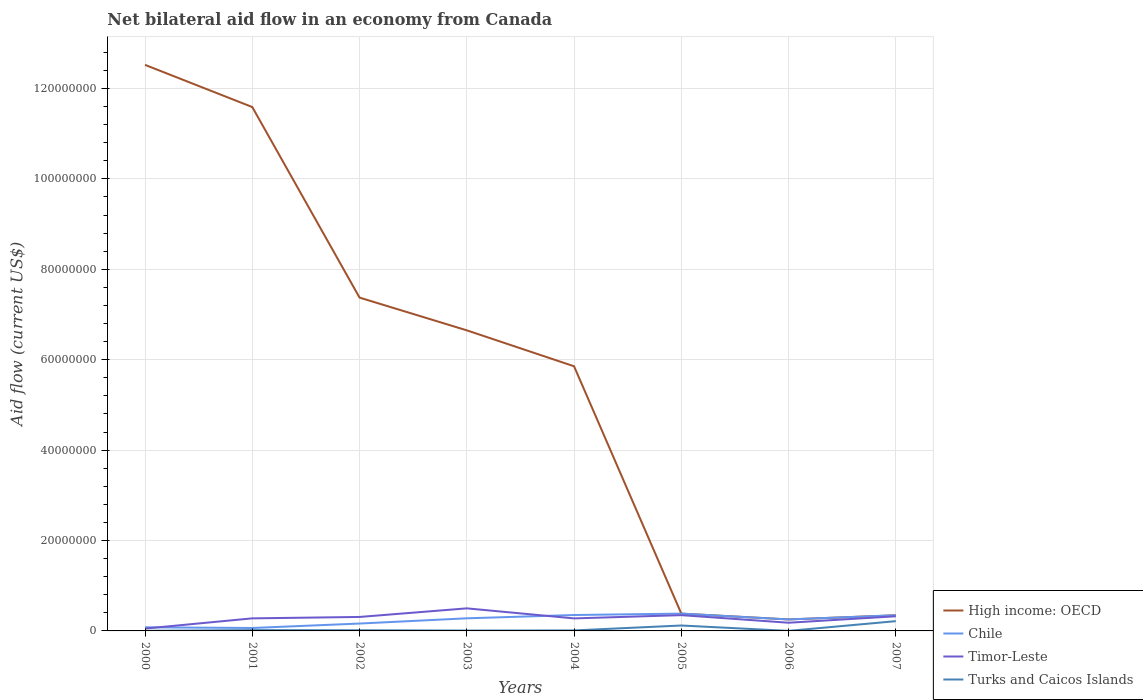Does the line corresponding to Chile intersect with the line corresponding to High income: OECD?
Offer a terse response. Yes. Is the number of lines equal to the number of legend labels?
Give a very brief answer. Yes. Across all years, what is the maximum net bilateral aid flow in Chile?
Your answer should be compact. 6.50e+05. What is the total net bilateral aid flow in High income: OECD in the graph?
Ensure brevity in your answer.  1.21e+08. What is the difference between the highest and the second highest net bilateral aid flow in Turks and Caicos Islands?
Offer a terse response. 2.15e+06. Is the net bilateral aid flow in Chile strictly greater than the net bilateral aid flow in Timor-Leste over the years?
Your answer should be very brief. No. How many lines are there?
Your response must be concise. 4. Are the values on the major ticks of Y-axis written in scientific E-notation?
Your response must be concise. No. How many legend labels are there?
Make the answer very short. 4. What is the title of the graph?
Ensure brevity in your answer.  Net bilateral aid flow in an economy from Canada. Does "Slovenia" appear as one of the legend labels in the graph?
Provide a succinct answer. No. What is the label or title of the X-axis?
Offer a very short reply. Years. What is the Aid flow (current US$) of High income: OECD in 2000?
Provide a succinct answer. 1.25e+08. What is the Aid flow (current US$) of Chile in 2000?
Make the answer very short. 8.00e+05. What is the Aid flow (current US$) in Timor-Leste in 2000?
Make the answer very short. 5.20e+05. What is the Aid flow (current US$) of Turks and Caicos Islands in 2000?
Provide a succinct answer. 3.00e+04. What is the Aid flow (current US$) of High income: OECD in 2001?
Offer a very short reply. 1.16e+08. What is the Aid flow (current US$) in Chile in 2001?
Keep it short and to the point. 6.50e+05. What is the Aid flow (current US$) of Timor-Leste in 2001?
Offer a terse response. 2.78e+06. What is the Aid flow (current US$) of High income: OECD in 2002?
Give a very brief answer. 7.37e+07. What is the Aid flow (current US$) in Chile in 2002?
Give a very brief answer. 1.63e+06. What is the Aid flow (current US$) in Timor-Leste in 2002?
Provide a short and direct response. 3.09e+06. What is the Aid flow (current US$) in Turks and Caicos Islands in 2002?
Ensure brevity in your answer.  1.50e+05. What is the Aid flow (current US$) of High income: OECD in 2003?
Give a very brief answer. 6.65e+07. What is the Aid flow (current US$) in Chile in 2003?
Give a very brief answer. 2.79e+06. What is the Aid flow (current US$) of Timor-Leste in 2003?
Offer a terse response. 4.99e+06. What is the Aid flow (current US$) in Turks and Caicos Islands in 2003?
Offer a terse response. 8.00e+04. What is the Aid flow (current US$) in High income: OECD in 2004?
Provide a succinct answer. 5.85e+07. What is the Aid flow (current US$) of Chile in 2004?
Your answer should be compact. 3.52e+06. What is the Aid flow (current US$) of Timor-Leste in 2004?
Ensure brevity in your answer.  2.77e+06. What is the Aid flow (current US$) of Turks and Caicos Islands in 2004?
Your response must be concise. 1.10e+05. What is the Aid flow (current US$) in High income: OECD in 2005?
Your response must be concise. 3.83e+06. What is the Aid flow (current US$) in Chile in 2005?
Ensure brevity in your answer.  3.83e+06. What is the Aid flow (current US$) of Timor-Leste in 2005?
Keep it short and to the point. 3.49e+06. What is the Aid flow (current US$) of Turks and Caicos Islands in 2005?
Offer a very short reply. 1.20e+06. What is the Aid flow (current US$) in High income: OECD in 2006?
Your answer should be compact. 2.54e+06. What is the Aid flow (current US$) of Chile in 2006?
Provide a short and direct response. 2.54e+06. What is the Aid flow (current US$) in Timor-Leste in 2006?
Ensure brevity in your answer.  1.81e+06. What is the Aid flow (current US$) of High income: OECD in 2007?
Provide a succinct answer. 3.46e+06. What is the Aid flow (current US$) in Chile in 2007?
Your response must be concise. 3.46e+06. What is the Aid flow (current US$) in Timor-Leste in 2007?
Your answer should be very brief. 3.24e+06. What is the Aid flow (current US$) in Turks and Caicos Islands in 2007?
Ensure brevity in your answer.  2.16e+06. Across all years, what is the maximum Aid flow (current US$) of High income: OECD?
Provide a short and direct response. 1.25e+08. Across all years, what is the maximum Aid flow (current US$) in Chile?
Your answer should be very brief. 3.83e+06. Across all years, what is the maximum Aid flow (current US$) of Timor-Leste?
Your response must be concise. 4.99e+06. Across all years, what is the maximum Aid flow (current US$) of Turks and Caicos Islands?
Offer a terse response. 2.16e+06. Across all years, what is the minimum Aid flow (current US$) in High income: OECD?
Your answer should be very brief. 2.54e+06. Across all years, what is the minimum Aid flow (current US$) in Chile?
Ensure brevity in your answer.  6.50e+05. Across all years, what is the minimum Aid flow (current US$) of Timor-Leste?
Your answer should be compact. 5.20e+05. Across all years, what is the minimum Aid flow (current US$) in Turks and Caicos Islands?
Your answer should be very brief. 10000. What is the total Aid flow (current US$) of High income: OECD in the graph?
Offer a terse response. 4.50e+08. What is the total Aid flow (current US$) of Chile in the graph?
Keep it short and to the point. 1.92e+07. What is the total Aid flow (current US$) of Timor-Leste in the graph?
Keep it short and to the point. 2.27e+07. What is the total Aid flow (current US$) in Turks and Caicos Islands in the graph?
Your answer should be very brief. 3.92e+06. What is the difference between the Aid flow (current US$) of High income: OECD in 2000 and that in 2001?
Keep it short and to the point. 9.33e+06. What is the difference between the Aid flow (current US$) of Chile in 2000 and that in 2001?
Your answer should be compact. 1.50e+05. What is the difference between the Aid flow (current US$) of Timor-Leste in 2000 and that in 2001?
Your answer should be compact. -2.26e+06. What is the difference between the Aid flow (current US$) in Turks and Caicos Islands in 2000 and that in 2001?
Keep it short and to the point. -1.50e+05. What is the difference between the Aid flow (current US$) in High income: OECD in 2000 and that in 2002?
Your answer should be compact. 5.15e+07. What is the difference between the Aid flow (current US$) of Chile in 2000 and that in 2002?
Provide a short and direct response. -8.30e+05. What is the difference between the Aid flow (current US$) in Timor-Leste in 2000 and that in 2002?
Give a very brief answer. -2.57e+06. What is the difference between the Aid flow (current US$) in High income: OECD in 2000 and that in 2003?
Your answer should be very brief. 5.87e+07. What is the difference between the Aid flow (current US$) of Chile in 2000 and that in 2003?
Ensure brevity in your answer.  -1.99e+06. What is the difference between the Aid flow (current US$) of Timor-Leste in 2000 and that in 2003?
Your response must be concise. -4.47e+06. What is the difference between the Aid flow (current US$) of High income: OECD in 2000 and that in 2004?
Keep it short and to the point. 6.67e+07. What is the difference between the Aid flow (current US$) in Chile in 2000 and that in 2004?
Your response must be concise. -2.72e+06. What is the difference between the Aid flow (current US$) of Timor-Leste in 2000 and that in 2004?
Keep it short and to the point. -2.25e+06. What is the difference between the Aid flow (current US$) in High income: OECD in 2000 and that in 2005?
Make the answer very short. 1.21e+08. What is the difference between the Aid flow (current US$) in Chile in 2000 and that in 2005?
Offer a very short reply. -3.03e+06. What is the difference between the Aid flow (current US$) in Timor-Leste in 2000 and that in 2005?
Make the answer very short. -2.97e+06. What is the difference between the Aid flow (current US$) of Turks and Caicos Islands in 2000 and that in 2005?
Provide a succinct answer. -1.17e+06. What is the difference between the Aid flow (current US$) in High income: OECD in 2000 and that in 2006?
Give a very brief answer. 1.23e+08. What is the difference between the Aid flow (current US$) of Chile in 2000 and that in 2006?
Your response must be concise. -1.74e+06. What is the difference between the Aid flow (current US$) of Timor-Leste in 2000 and that in 2006?
Your response must be concise. -1.29e+06. What is the difference between the Aid flow (current US$) of High income: OECD in 2000 and that in 2007?
Give a very brief answer. 1.22e+08. What is the difference between the Aid flow (current US$) in Chile in 2000 and that in 2007?
Offer a terse response. -2.66e+06. What is the difference between the Aid flow (current US$) of Timor-Leste in 2000 and that in 2007?
Offer a terse response. -2.72e+06. What is the difference between the Aid flow (current US$) in Turks and Caicos Islands in 2000 and that in 2007?
Your response must be concise. -2.13e+06. What is the difference between the Aid flow (current US$) in High income: OECD in 2001 and that in 2002?
Ensure brevity in your answer.  4.22e+07. What is the difference between the Aid flow (current US$) in Chile in 2001 and that in 2002?
Offer a terse response. -9.80e+05. What is the difference between the Aid flow (current US$) in Timor-Leste in 2001 and that in 2002?
Ensure brevity in your answer.  -3.10e+05. What is the difference between the Aid flow (current US$) of High income: OECD in 2001 and that in 2003?
Ensure brevity in your answer.  4.94e+07. What is the difference between the Aid flow (current US$) of Chile in 2001 and that in 2003?
Offer a terse response. -2.14e+06. What is the difference between the Aid flow (current US$) in Timor-Leste in 2001 and that in 2003?
Make the answer very short. -2.21e+06. What is the difference between the Aid flow (current US$) of High income: OECD in 2001 and that in 2004?
Provide a short and direct response. 5.73e+07. What is the difference between the Aid flow (current US$) in Chile in 2001 and that in 2004?
Your answer should be very brief. -2.87e+06. What is the difference between the Aid flow (current US$) in High income: OECD in 2001 and that in 2005?
Ensure brevity in your answer.  1.12e+08. What is the difference between the Aid flow (current US$) of Chile in 2001 and that in 2005?
Give a very brief answer. -3.18e+06. What is the difference between the Aid flow (current US$) in Timor-Leste in 2001 and that in 2005?
Give a very brief answer. -7.10e+05. What is the difference between the Aid flow (current US$) of Turks and Caicos Islands in 2001 and that in 2005?
Keep it short and to the point. -1.02e+06. What is the difference between the Aid flow (current US$) in High income: OECD in 2001 and that in 2006?
Offer a very short reply. 1.13e+08. What is the difference between the Aid flow (current US$) in Chile in 2001 and that in 2006?
Your answer should be compact. -1.89e+06. What is the difference between the Aid flow (current US$) of Timor-Leste in 2001 and that in 2006?
Your answer should be compact. 9.70e+05. What is the difference between the Aid flow (current US$) in High income: OECD in 2001 and that in 2007?
Offer a very short reply. 1.12e+08. What is the difference between the Aid flow (current US$) of Chile in 2001 and that in 2007?
Ensure brevity in your answer.  -2.81e+06. What is the difference between the Aid flow (current US$) in Timor-Leste in 2001 and that in 2007?
Your answer should be very brief. -4.60e+05. What is the difference between the Aid flow (current US$) in Turks and Caicos Islands in 2001 and that in 2007?
Offer a very short reply. -1.98e+06. What is the difference between the Aid flow (current US$) of High income: OECD in 2002 and that in 2003?
Offer a very short reply. 7.24e+06. What is the difference between the Aid flow (current US$) in Chile in 2002 and that in 2003?
Provide a succinct answer. -1.16e+06. What is the difference between the Aid flow (current US$) in Timor-Leste in 2002 and that in 2003?
Ensure brevity in your answer.  -1.90e+06. What is the difference between the Aid flow (current US$) of Turks and Caicos Islands in 2002 and that in 2003?
Make the answer very short. 7.00e+04. What is the difference between the Aid flow (current US$) in High income: OECD in 2002 and that in 2004?
Make the answer very short. 1.52e+07. What is the difference between the Aid flow (current US$) of Chile in 2002 and that in 2004?
Make the answer very short. -1.89e+06. What is the difference between the Aid flow (current US$) of Timor-Leste in 2002 and that in 2004?
Provide a succinct answer. 3.20e+05. What is the difference between the Aid flow (current US$) of Turks and Caicos Islands in 2002 and that in 2004?
Offer a very short reply. 4.00e+04. What is the difference between the Aid flow (current US$) of High income: OECD in 2002 and that in 2005?
Make the answer very short. 6.99e+07. What is the difference between the Aid flow (current US$) of Chile in 2002 and that in 2005?
Provide a short and direct response. -2.20e+06. What is the difference between the Aid flow (current US$) of Timor-Leste in 2002 and that in 2005?
Offer a very short reply. -4.00e+05. What is the difference between the Aid flow (current US$) in Turks and Caicos Islands in 2002 and that in 2005?
Offer a very short reply. -1.05e+06. What is the difference between the Aid flow (current US$) in High income: OECD in 2002 and that in 2006?
Your answer should be very brief. 7.12e+07. What is the difference between the Aid flow (current US$) of Chile in 2002 and that in 2006?
Make the answer very short. -9.10e+05. What is the difference between the Aid flow (current US$) of Timor-Leste in 2002 and that in 2006?
Ensure brevity in your answer.  1.28e+06. What is the difference between the Aid flow (current US$) in High income: OECD in 2002 and that in 2007?
Your response must be concise. 7.03e+07. What is the difference between the Aid flow (current US$) of Chile in 2002 and that in 2007?
Your response must be concise. -1.83e+06. What is the difference between the Aid flow (current US$) of Timor-Leste in 2002 and that in 2007?
Provide a short and direct response. -1.50e+05. What is the difference between the Aid flow (current US$) of Turks and Caicos Islands in 2002 and that in 2007?
Provide a short and direct response. -2.01e+06. What is the difference between the Aid flow (current US$) of High income: OECD in 2003 and that in 2004?
Keep it short and to the point. 7.95e+06. What is the difference between the Aid flow (current US$) of Chile in 2003 and that in 2004?
Offer a very short reply. -7.30e+05. What is the difference between the Aid flow (current US$) in Timor-Leste in 2003 and that in 2004?
Provide a succinct answer. 2.22e+06. What is the difference between the Aid flow (current US$) in High income: OECD in 2003 and that in 2005?
Your response must be concise. 6.27e+07. What is the difference between the Aid flow (current US$) of Chile in 2003 and that in 2005?
Keep it short and to the point. -1.04e+06. What is the difference between the Aid flow (current US$) of Timor-Leste in 2003 and that in 2005?
Provide a short and direct response. 1.50e+06. What is the difference between the Aid flow (current US$) in Turks and Caicos Islands in 2003 and that in 2005?
Provide a succinct answer. -1.12e+06. What is the difference between the Aid flow (current US$) of High income: OECD in 2003 and that in 2006?
Your response must be concise. 6.40e+07. What is the difference between the Aid flow (current US$) of Timor-Leste in 2003 and that in 2006?
Your answer should be compact. 3.18e+06. What is the difference between the Aid flow (current US$) in High income: OECD in 2003 and that in 2007?
Make the answer very short. 6.30e+07. What is the difference between the Aid flow (current US$) in Chile in 2003 and that in 2007?
Ensure brevity in your answer.  -6.70e+05. What is the difference between the Aid flow (current US$) of Timor-Leste in 2003 and that in 2007?
Your response must be concise. 1.75e+06. What is the difference between the Aid flow (current US$) in Turks and Caicos Islands in 2003 and that in 2007?
Provide a short and direct response. -2.08e+06. What is the difference between the Aid flow (current US$) of High income: OECD in 2004 and that in 2005?
Your response must be concise. 5.47e+07. What is the difference between the Aid flow (current US$) in Chile in 2004 and that in 2005?
Offer a very short reply. -3.10e+05. What is the difference between the Aid flow (current US$) of Timor-Leste in 2004 and that in 2005?
Give a very brief answer. -7.20e+05. What is the difference between the Aid flow (current US$) of Turks and Caicos Islands in 2004 and that in 2005?
Keep it short and to the point. -1.09e+06. What is the difference between the Aid flow (current US$) in High income: OECD in 2004 and that in 2006?
Ensure brevity in your answer.  5.60e+07. What is the difference between the Aid flow (current US$) in Chile in 2004 and that in 2006?
Offer a terse response. 9.80e+05. What is the difference between the Aid flow (current US$) in Timor-Leste in 2004 and that in 2006?
Your response must be concise. 9.60e+05. What is the difference between the Aid flow (current US$) of Turks and Caicos Islands in 2004 and that in 2006?
Make the answer very short. 1.00e+05. What is the difference between the Aid flow (current US$) of High income: OECD in 2004 and that in 2007?
Give a very brief answer. 5.51e+07. What is the difference between the Aid flow (current US$) of Chile in 2004 and that in 2007?
Make the answer very short. 6.00e+04. What is the difference between the Aid flow (current US$) in Timor-Leste in 2004 and that in 2007?
Your answer should be very brief. -4.70e+05. What is the difference between the Aid flow (current US$) of Turks and Caicos Islands in 2004 and that in 2007?
Your answer should be compact. -2.05e+06. What is the difference between the Aid flow (current US$) in High income: OECD in 2005 and that in 2006?
Give a very brief answer. 1.29e+06. What is the difference between the Aid flow (current US$) of Chile in 2005 and that in 2006?
Offer a terse response. 1.29e+06. What is the difference between the Aid flow (current US$) of Timor-Leste in 2005 and that in 2006?
Offer a terse response. 1.68e+06. What is the difference between the Aid flow (current US$) of Turks and Caicos Islands in 2005 and that in 2006?
Your answer should be very brief. 1.19e+06. What is the difference between the Aid flow (current US$) in Turks and Caicos Islands in 2005 and that in 2007?
Offer a terse response. -9.60e+05. What is the difference between the Aid flow (current US$) in High income: OECD in 2006 and that in 2007?
Make the answer very short. -9.20e+05. What is the difference between the Aid flow (current US$) in Chile in 2006 and that in 2007?
Make the answer very short. -9.20e+05. What is the difference between the Aid flow (current US$) of Timor-Leste in 2006 and that in 2007?
Keep it short and to the point. -1.43e+06. What is the difference between the Aid flow (current US$) of Turks and Caicos Islands in 2006 and that in 2007?
Your response must be concise. -2.15e+06. What is the difference between the Aid flow (current US$) in High income: OECD in 2000 and the Aid flow (current US$) in Chile in 2001?
Your response must be concise. 1.25e+08. What is the difference between the Aid flow (current US$) of High income: OECD in 2000 and the Aid flow (current US$) of Timor-Leste in 2001?
Your response must be concise. 1.22e+08. What is the difference between the Aid flow (current US$) in High income: OECD in 2000 and the Aid flow (current US$) in Turks and Caicos Islands in 2001?
Ensure brevity in your answer.  1.25e+08. What is the difference between the Aid flow (current US$) in Chile in 2000 and the Aid flow (current US$) in Timor-Leste in 2001?
Your answer should be very brief. -1.98e+06. What is the difference between the Aid flow (current US$) of Chile in 2000 and the Aid flow (current US$) of Turks and Caicos Islands in 2001?
Ensure brevity in your answer.  6.20e+05. What is the difference between the Aid flow (current US$) of Timor-Leste in 2000 and the Aid flow (current US$) of Turks and Caicos Islands in 2001?
Provide a short and direct response. 3.40e+05. What is the difference between the Aid flow (current US$) in High income: OECD in 2000 and the Aid flow (current US$) in Chile in 2002?
Offer a very short reply. 1.24e+08. What is the difference between the Aid flow (current US$) of High income: OECD in 2000 and the Aid flow (current US$) of Timor-Leste in 2002?
Offer a very short reply. 1.22e+08. What is the difference between the Aid flow (current US$) of High income: OECD in 2000 and the Aid flow (current US$) of Turks and Caicos Islands in 2002?
Offer a terse response. 1.25e+08. What is the difference between the Aid flow (current US$) of Chile in 2000 and the Aid flow (current US$) of Timor-Leste in 2002?
Ensure brevity in your answer.  -2.29e+06. What is the difference between the Aid flow (current US$) of Chile in 2000 and the Aid flow (current US$) of Turks and Caicos Islands in 2002?
Provide a short and direct response. 6.50e+05. What is the difference between the Aid flow (current US$) of High income: OECD in 2000 and the Aid flow (current US$) of Chile in 2003?
Your answer should be compact. 1.22e+08. What is the difference between the Aid flow (current US$) of High income: OECD in 2000 and the Aid flow (current US$) of Timor-Leste in 2003?
Keep it short and to the point. 1.20e+08. What is the difference between the Aid flow (current US$) of High income: OECD in 2000 and the Aid flow (current US$) of Turks and Caicos Islands in 2003?
Ensure brevity in your answer.  1.25e+08. What is the difference between the Aid flow (current US$) in Chile in 2000 and the Aid flow (current US$) in Timor-Leste in 2003?
Your response must be concise. -4.19e+06. What is the difference between the Aid flow (current US$) in Chile in 2000 and the Aid flow (current US$) in Turks and Caicos Islands in 2003?
Offer a terse response. 7.20e+05. What is the difference between the Aid flow (current US$) of High income: OECD in 2000 and the Aid flow (current US$) of Chile in 2004?
Keep it short and to the point. 1.22e+08. What is the difference between the Aid flow (current US$) of High income: OECD in 2000 and the Aid flow (current US$) of Timor-Leste in 2004?
Ensure brevity in your answer.  1.22e+08. What is the difference between the Aid flow (current US$) in High income: OECD in 2000 and the Aid flow (current US$) in Turks and Caicos Islands in 2004?
Give a very brief answer. 1.25e+08. What is the difference between the Aid flow (current US$) in Chile in 2000 and the Aid flow (current US$) in Timor-Leste in 2004?
Your answer should be compact. -1.97e+06. What is the difference between the Aid flow (current US$) in Chile in 2000 and the Aid flow (current US$) in Turks and Caicos Islands in 2004?
Offer a very short reply. 6.90e+05. What is the difference between the Aid flow (current US$) of Timor-Leste in 2000 and the Aid flow (current US$) of Turks and Caicos Islands in 2004?
Ensure brevity in your answer.  4.10e+05. What is the difference between the Aid flow (current US$) in High income: OECD in 2000 and the Aid flow (current US$) in Chile in 2005?
Your answer should be compact. 1.21e+08. What is the difference between the Aid flow (current US$) of High income: OECD in 2000 and the Aid flow (current US$) of Timor-Leste in 2005?
Your answer should be compact. 1.22e+08. What is the difference between the Aid flow (current US$) of High income: OECD in 2000 and the Aid flow (current US$) of Turks and Caicos Islands in 2005?
Your answer should be compact. 1.24e+08. What is the difference between the Aid flow (current US$) of Chile in 2000 and the Aid flow (current US$) of Timor-Leste in 2005?
Provide a short and direct response. -2.69e+06. What is the difference between the Aid flow (current US$) of Chile in 2000 and the Aid flow (current US$) of Turks and Caicos Islands in 2005?
Provide a short and direct response. -4.00e+05. What is the difference between the Aid flow (current US$) in Timor-Leste in 2000 and the Aid flow (current US$) in Turks and Caicos Islands in 2005?
Make the answer very short. -6.80e+05. What is the difference between the Aid flow (current US$) in High income: OECD in 2000 and the Aid flow (current US$) in Chile in 2006?
Give a very brief answer. 1.23e+08. What is the difference between the Aid flow (current US$) in High income: OECD in 2000 and the Aid flow (current US$) in Timor-Leste in 2006?
Offer a very short reply. 1.23e+08. What is the difference between the Aid flow (current US$) of High income: OECD in 2000 and the Aid flow (current US$) of Turks and Caicos Islands in 2006?
Your response must be concise. 1.25e+08. What is the difference between the Aid flow (current US$) in Chile in 2000 and the Aid flow (current US$) in Timor-Leste in 2006?
Ensure brevity in your answer.  -1.01e+06. What is the difference between the Aid flow (current US$) in Chile in 2000 and the Aid flow (current US$) in Turks and Caicos Islands in 2006?
Keep it short and to the point. 7.90e+05. What is the difference between the Aid flow (current US$) of Timor-Leste in 2000 and the Aid flow (current US$) of Turks and Caicos Islands in 2006?
Provide a succinct answer. 5.10e+05. What is the difference between the Aid flow (current US$) of High income: OECD in 2000 and the Aid flow (current US$) of Chile in 2007?
Provide a short and direct response. 1.22e+08. What is the difference between the Aid flow (current US$) of High income: OECD in 2000 and the Aid flow (current US$) of Timor-Leste in 2007?
Offer a very short reply. 1.22e+08. What is the difference between the Aid flow (current US$) in High income: OECD in 2000 and the Aid flow (current US$) in Turks and Caicos Islands in 2007?
Your response must be concise. 1.23e+08. What is the difference between the Aid flow (current US$) of Chile in 2000 and the Aid flow (current US$) of Timor-Leste in 2007?
Make the answer very short. -2.44e+06. What is the difference between the Aid flow (current US$) of Chile in 2000 and the Aid flow (current US$) of Turks and Caicos Islands in 2007?
Your answer should be very brief. -1.36e+06. What is the difference between the Aid flow (current US$) in Timor-Leste in 2000 and the Aid flow (current US$) in Turks and Caicos Islands in 2007?
Your response must be concise. -1.64e+06. What is the difference between the Aid flow (current US$) of High income: OECD in 2001 and the Aid flow (current US$) of Chile in 2002?
Give a very brief answer. 1.14e+08. What is the difference between the Aid flow (current US$) in High income: OECD in 2001 and the Aid flow (current US$) in Timor-Leste in 2002?
Ensure brevity in your answer.  1.13e+08. What is the difference between the Aid flow (current US$) of High income: OECD in 2001 and the Aid flow (current US$) of Turks and Caicos Islands in 2002?
Your answer should be very brief. 1.16e+08. What is the difference between the Aid flow (current US$) in Chile in 2001 and the Aid flow (current US$) in Timor-Leste in 2002?
Offer a terse response. -2.44e+06. What is the difference between the Aid flow (current US$) of Chile in 2001 and the Aid flow (current US$) of Turks and Caicos Islands in 2002?
Keep it short and to the point. 5.00e+05. What is the difference between the Aid flow (current US$) in Timor-Leste in 2001 and the Aid flow (current US$) in Turks and Caicos Islands in 2002?
Provide a succinct answer. 2.63e+06. What is the difference between the Aid flow (current US$) in High income: OECD in 2001 and the Aid flow (current US$) in Chile in 2003?
Keep it short and to the point. 1.13e+08. What is the difference between the Aid flow (current US$) in High income: OECD in 2001 and the Aid flow (current US$) in Timor-Leste in 2003?
Your answer should be very brief. 1.11e+08. What is the difference between the Aid flow (current US$) of High income: OECD in 2001 and the Aid flow (current US$) of Turks and Caicos Islands in 2003?
Your answer should be compact. 1.16e+08. What is the difference between the Aid flow (current US$) in Chile in 2001 and the Aid flow (current US$) in Timor-Leste in 2003?
Offer a terse response. -4.34e+06. What is the difference between the Aid flow (current US$) in Chile in 2001 and the Aid flow (current US$) in Turks and Caicos Islands in 2003?
Your response must be concise. 5.70e+05. What is the difference between the Aid flow (current US$) in Timor-Leste in 2001 and the Aid flow (current US$) in Turks and Caicos Islands in 2003?
Your answer should be very brief. 2.70e+06. What is the difference between the Aid flow (current US$) of High income: OECD in 2001 and the Aid flow (current US$) of Chile in 2004?
Offer a very short reply. 1.12e+08. What is the difference between the Aid flow (current US$) of High income: OECD in 2001 and the Aid flow (current US$) of Timor-Leste in 2004?
Provide a short and direct response. 1.13e+08. What is the difference between the Aid flow (current US$) in High income: OECD in 2001 and the Aid flow (current US$) in Turks and Caicos Islands in 2004?
Your answer should be compact. 1.16e+08. What is the difference between the Aid flow (current US$) in Chile in 2001 and the Aid flow (current US$) in Timor-Leste in 2004?
Ensure brevity in your answer.  -2.12e+06. What is the difference between the Aid flow (current US$) of Chile in 2001 and the Aid flow (current US$) of Turks and Caicos Islands in 2004?
Give a very brief answer. 5.40e+05. What is the difference between the Aid flow (current US$) in Timor-Leste in 2001 and the Aid flow (current US$) in Turks and Caicos Islands in 2004?
Keep it short and to the point. 2.67e+06. What is the difference between the Aid flow (current US$) of High income: OECD in 2001 and the Aid flow (current US$) of Chile in 2005?
Your answer should be very brief. 1.12e+08. What is the difference between the Aid flow (current US$) of High income: OECD in 2001 and the Aid flow (current US$) of Timor-Leste in 2005?
Provide a short and direct response. 1.12e+08. What is the difference between the Aid flow (current US$) of High income: OECD in 2001 and the Aid flow (current US$) of Turks and Caicos Islands in 2005?
Your answer should be compact. 1.15e+08. What is the difference between the Aid flow (current US$) in Chile in 2001 and the Aid flow (current US$) in Timor-Leste in 2005?
Your answer should be very brief. -2.84e+06. What is the difference between the Aid flow (current US$) in Chile in 2001 and the Aid flow (current US$) in Turks and Caicos Islands in 2005?
Offer a terse response. -5.50e+05. What is the difference between the Aid flow (current US$) in Timor-Leste in 2001 and the Aid flow (current US$) in Turks and Caicos Islands in 2005?
Ensure brevity in your answer.  1.58e+06. What is the difference between the Aid flow (current US$) of High income: OECD in 2001 and the Aid flow (current US$) of Chile in 2006?
Provide a succinct answer. 1.13e+08. What is the difference between the Aid flow (current US$) of High income: OECD in 2001 and the Aid flow (current US$) of Timor-Leste in 2006?
Your response must be concise. 1.14e+08. What is the difference between the Aid flow (current US$) in High income: OECD in 2001 and the Aid flow (current US$) in Turks and Caicos Islands in 2006?
Your answer should be very brief. 1.16e+08. What is the difference between the Aid flow (current US$) of Chile in 2001 and the Aid flow (current US$) of Timor-Leste in 2006?
Offer a very short reply. -1.16e+06. What is the difference between the Aid flow (current US$) in Chile in 2001 and the Aid flow (current US$) in Turks and Caicos Islands in 2006?
Make the answer very short. 6.40e+05. What is the difference between the Aid flow (current US$) in Timor-Leste in 2001 and the Aid flow (current US$) in Turks and Caicos Islands in 2006?
Provide a succinct answer. 2.77e+06. What is the difference between the Aid flow (current US$) of High income: OECD in 2001 and the Aid flow (current US$) of Chile in 2007?
Provide a succinct answer. 1.12e+08. What is the difference between the Aid flow (current US$) in High income: OECD in 2001 and the Aid flow (current US$) in Timor-Leste in 2007?
Make the answer very short. 1.13e+08. What is the difference between the Aid flow (current US$) of High income: OECD in 2001 and the Aid flow (current US$) of Turks and Caicos Islands in 2007?
Keep it short and to the point. 1.14e+08. What is the difference between the Aid flow (current US$) in Chile in 2001 and the Aid flow (current US$) in Timor-Leste in 2007?
Provide a short and direct response. -2.59e+06. What is the difference between the Aid flow (current US$) in Chile in 2001 and the Aid flow (current US$) in Turks and Caicos Islands in 2007?
Offer a very short reply. -1.51e+06. What is the difference between the Aid flow (current US$) of Timor-Leste in 2001 and the Aid flow (current US$) of Turks and Caicos Islands in 2007?
Ensure brevity in your answer.  6.20e+05. What is the difference between the Aid flow (current US$) in High income: OECD in 2002 and the Aid flow (current US$) in Chile in 2003?
Your response must be concise. 7.09e+07. What is the difference between the Aid flow (current US$) in High income: OECD in 2002 and the Aid flow (current US$) in Timor-Leste in 2003?
Your answer should be very brief. 6.87e+07. What is the difference between the Aid flow (current US$) of High income: OECD in 2002 and the Aid flow (current US$) of Turks and Caicos Islands in 2003?
Offer a terse response. 7.36e+07. What is the difference between the Aid flow (current US$) in Chile in 2002 and the Aid flow (current US$) in Timor-Leste in 2003?
Make the answer very short. -3.36e+06. What is the difference between the Aid flow (current US$) of Chile in 2002 and the Aid flow (current US$) of Turks and Caicos Islands in 2003?
Your response must be concise. 1.55e+06. What is the difference between the Aid flow (current US$) in Timor-Leste in 2002 and the Aid flow (current US$) in Turks and Caicos Islands in 2003?
Your answer should be compact. 3.01e+06. What is the difference between the Aid flow (current US$) of High income: OECD in 2002 and the Aid flow (current US$) of Chile in 2004?
Ensure brevity in your answer.  7.02e+07. What is the difference between the Aid flow (current US$) of High income: OECD in 2002 and the Aid flow (current US$) of Timor-Leste in 2004?
Give a very brief answer. 7.10e+07. What is the difference between the Aid flow (current US$) of High income: OECD in 2002 and the Aid flow (current US$) of Turks and Caicos Islands in 2004?
Provide a succinct answer. 7.36e+07. What is the difference between the Aid flow (current US$) of Chile in 2002 and the Aid flow (current US$) of Timor-Leste in 2004?
Offer a terse response. -1.14e+06. What is the difference between the Aid flow (current US$) in Chile in 2002 and the Aid flow (current US$) in Turks and Caicos Islands in 2004?
Your response must be concise. 1.52e+06. What is the difference between the Aid flow (current US$) in Timor-Leste in 2002 and the Aid flow (current US$) in Turks and Caicos Islands in 2004?
Your response must be concise. 2.98e+06. What is the difference between the Aid flow (current US$) in High income: OECD in 2002 and the Aid flow (current US$) in Chile in 2005?
Give a very brief answer. 6.99e+07. What is the difference between the Aid flow (current US$) of High income: OECD in 2002 and the Aid flow (current US$) of Timor-Leste in 2005?
Provide a succinct answer. 7.02e+07. What is the difference between the Aid flow (current US$) of High income: OECD in 2002 and the Aid flow (current US$) of Turks and Caicos Islands in 2005?
Your answer should be compact. 7.25e+07. What is the difference between the Aid flow (current US$) in Chile in 2002 and the Aid flow (current US$) in Timor-Leste in 2005?
Keep it short and to the point. -1.86e+06. What is the difference between the Aid flow (current US$) in Timor-Leste in 2002 and the Aid flow (current US$) in Turks and Caicos Islands in 2005?
Offer a terse response. 1.89e+06. What is the difference between the Aid flow (current US$) of High income: OECD in 2002 and the Aid flow (current US$) of Chile in 2006?
Your answer should be compact. 7.12e+07. What is the difference between the Aid flow (current US$) of High income: OECD in 2002 and the Aid flow (current US$) of Timor-Leste in 2006?
Offer a terse response. 7.19e+07. What is the difference between the Aid flow (current US$) in High income: OECD in 2002 and the Aid flow (current US$) in Turks and Caicos Islands in 2006?
Your answer should be compact. 7.37e+07. What is the difference between the Aid flow (current US$) of Chile in 2002 and the Aid flow (current US$) of Turks and Caicos Islands in 2006?
Give a very brief answer. 1.62e+06. What is the difference between the Aid flow (current US$) in Timor-Leste in 2002 and the Aid flow (current US$) in Turks and Caicos Islands in 2006?
Provide a short and direct response. 3.08e+06. What is the difference between the Aid flow (current US$) of High income: OECD in 2002 and the Aid flow (current US$) of Chile in 2007?
Offer a terse response. 7.03e+07. What is the difference between the Aid flow (current US$) in High income: OECD in 2002 and the Aid flow (current US$) in Timor-Leste in 2007?
Offer a very short reply. 7.05e+07. What is the difference between the Aid flow (current US$) of High income: OECD in 2002 and the Aid flow (current US$) of Turks and Caicos Islands in 2007?
Provide a short and direct response. 7.16e+07. What is the difference between the Aid flow (current US$) of Chile in 2002 and the Aid flow (current US$) of Timor-Leste in 2007?
Provide a succinct answer. -1.61e+06. What is the difference between the Aid flow (current US$) of Chile in 2002 and the Aid flow (current US$) of Turks and Caicos Islands in 2007?
Offer a terse response. -5.30e+05. What is the difference between the Aid flow (current US$) in Timor-Leste in 2002 and the Aid flow (current US$) in Turks and Caicos Islands in 2007?
Make the answer very short. 9.30e+05. What is the difference between the Aid flow (current US$) in High income: OECD in 2003 and the Aid flow (current US$) in Chile in 2004?
Give a very brief answer. 6.30e+07. What is the difference between the Aid flow (current US$) in High income: OECD in 2003 and the Aid flow (current US$) in Timor-Leste in 2004?
Your answer should be very brief. 6.37e+07. What is the difference between the Aid flow (current US$) in High income: OECD in 2003 and the Aid flow (current US$) in Turks and Caicos Islands in 2004?
Your answer should be compact. 6.64e+07. What is the difference between the Aid flow (current US$) in Chile in 2003 and the Aid flow (current US$) in Turks and Caicos Islands in 2004?
Provide a short and direct response. 2.68e+06. What is the difference between the Aid flow (current US$) in Timor-Leste in 2003 and the Aid flow (current US$) in Turks and Caicos Islands in 2004?
Ensure brevity in your answer.  4.88e+06. What is the difference between the Aid flow (current US$) of High income: OECD in 2003 and the Aid flow (current US$) of Chile in 2005?
Ensure brevity in your answer.  6.27e+07. What is the difference between the Aid flow (current US$) of High income: OECD in 2003 and the Aid flow (current US$) of Timor-Leste in 2005?
Keep it short and to the point. 6.30e+07. What is the difference between the Aid flow (current US$) in High income: OECD in 2003 and the Aid flow (current US$) in Turks and Caicos Islands in 2005?
Offer a terse response. 6.53e+07. What is the difference between the Aid flow (current US$) in Chile in 2003 and the Aid flow (current US$) in Timor-Leste in 2005?
Offer a very short reply. -7.00e+05. What is the difference between the Aid flow (current US$) of Chile in 2003 and the Aid flow (current US$) of Turks and Caicos Islands in 2005?
Offer a terse response. 1.59e+06. What is the difference between the Aid flow (current US$) of Timor-Leste in 2003 and the Aid flow (current US$) of Turks and Caicos Islands in 2005?
Offer a terse response. 3.79e+06. What is the difference between the Aid flow (current US$) of High income: OECD in 2003 and the Aid flow (current US$) of Chile in 2006?
Give a very brief answer. 6.40e+07. What is the difference between the Aid flow (current US$) in High income: OECD in 2003 and the Aid flow (current US$) in Timor-Leste in 2006?
Your response must be concise. 6.47e+07. What is the difference between the Aid flow (current US$) of High income: OECD in 2003 and the Aid flow (current US$) of Turks and Caicos Islands in 2006?
Provide a succinct answer. 6.65e+07. What is the difference between the Aid flow (current US$) in Chile in 2003 and the Aid flow (current US$) in Timor-Leste in 2006?
Offer a terse response. 9.80e+05. What is the difference between the Aid flow (current US$) in Chile in 2003 and the Aid flow (current US$) in Turks and Caicos Islands in 2006?
Your response must be concise. 2.78e+06. What is the difference between the Aid flow (current US$) of Timor-Leste in 2003 and the Aid flow (current US$) of Turks and Caicos Islands in 2006?
Your answer should be compact. 4.98e+06. What is the difference between the Aid flow (current US$) in High income: OECD in 2003 and the Aid flow (current US$) in Chile in 2007?
Ensure brevity in your answer.  6.30e+07. What is the difference between the Aid flow (current US$) of High income: OECD in 2003 and the Aid flow (current US$) of Timor-Leste in 2007?
Make the answer very short. 6.32e+07. What is the difference between the Aid flow (current US$) of High income: OECD in 2003 and the Aid flow (current US$) of Turks and Caicos Islands in 2007?
Your answer should be compact. 6.43e+07. What is the difference between the Aid flow (current US$) in Chile in 2003 and the Aid flow (current US$) in Timor-Leste in 2007?
Offer a very short reply. -4.50e+05. What is the difference between the Aid flow (current US$) in Chile in 2003 and the Aid flow (current US$) in Turks and Caicos Islands in 2007?
Provide a succinct answer. 6.30e+05. What is the difference between the Aid flow (current US$) of Timor-Leste in 2003 and the Aid flow (current US$) of Turks and Caicos Islands in 2007?
Your answer should be very brief. 2.83e+06. What is the difference between the Aid flow (current US$) of High income: OECD in 2004 and the Aid flow (current US$) of Chile in 2005?
Provide a short and direct response. 5.47e+07. What is the difference between the Aid flow (current US$) in High income: OECD in 2004 and the Aid flow (current US$) in Timor-Leste in 2005?
Provide a succinct answer. 5.50e+07. What is the difference between the Aid flow (current US$) in High income: OECD in 2004 and the Aid flow (current US$) in Turks and Caicos Islands in 2005?
Provide a succinct answer. 5.73e+07. What is the difference between the Aid flow (current US$) in Chile in 2004 and the Aid flow (current US$) in Timor-Leste in 2005?
Offer a very short reply. 3.00e+04. What is the difference between the Aid flow (current US$) of Chile in 2004 and the Aid flow (current US$) of Turks and Caicos Islands in 2005?
Make the answer very short. 2.32e+06. What is the difference between the Aid flow (current US$) in Timor-Leste in 2004 and the Aid flow (current US$) in Turks and Caicos Islands in 2005?
Provide a short and direct response. 1.57e+06. What is the difference between the Aid flow (current US$) of High income: OECD in 2004 and the Aid flow (current US$) of Chile in 2006?
Make the answer very short. 5.60e+07. What is the difference between the Aid flow (current US$) of High income: OECD in 2004 and the Aid flow (current US$) of Timor-Leste in 2006?
Offer a very short reply. 5.67e+07. What is the difference between the Aid flow (current US$) in High income: OECD in 2004 and the Aid flow (current US$) in Turks and Caicos Islands in 2006?
Ensure brevity in your answer.  5.85e+07. What is the difference between the Aid flow (current US$) of Chile in 2004 and the Aid flow (current US$) of Timor-Leste in 2006?
Your response must be concise. 1.71e+06. What is the difference between the Aid flow (current US$) in Chile in 2004 and the Aid flow (current US$) in Turks and Caicos Islands in 2006?
Your answer should be compact. 3.51e+06. What is the difference between the Aid flow (current US$) in Timor-Leste in 2004 and the Aid flow (current US$) in Turks and Caicos Islands in 2006?
Your answer should be compact. 2.76e+06. What is the difference between the Aid flow (current US$) of High income: OECD in 2004 and the Aid flow (current US$) of Chile in 2007?
Offer a very short reply. 5.51e+07. What is the difference between the Aid flow (current US$) in High income: OECD in 2004 and the Aid flow (current US$) in Timor-Leste in 2007?
Offer a very short reply. 5.53e+07. What is the difference between the Aid flow (current US$) in High income: OECD in 2004 and the Aid flow (current US$) in Turks and Caicos Islands in 2007?
Keep it short and to the point. 5.64e+07. What is the difference between the Aid flow (current US$) in Chile in 2004 and the Aid flow (current US$) in Turks and Caicos Islands in 2007?
Offer a very short reply. 1.36e+06. What is the difference between the Aid flow (current US$) in High income: OECD in 2005 and the Aid flow (current US$) in Chile in 2006?
Your answer should be compact. 1.29e+06. What is the difference between the Aid flow (current US$) in High income: OECD in 2005 and the Aid flow (current US$) in Timor-Leste in 2006?
Make the answer very short. 2.02e+06. What is the difference between the Aid flow (current US$) of High income: OECD in 2005 and the Aid flow (current US$) of Turks and Caicos Islands in 2006?
Give a very brief answer. 3.82e+06. What is the difference between the Aid flow (current US$) in Chile in 2005 and the Aid flow (current US$) in Timor-Leste in 2006?
Ensure brevity in your answer.  2.02e+06. What is the difference between the Aid flow (current US$) in Chile in 2005 and the Aid flow (current US$) in Turks and Caicos Islands in 2006?
Offer a terse response. 3.82e+06. What is the difference between the Aid flow (current US$) in Timor-Leste in 2005 and the Aid flow (current US$) in Turks and Caicos Islands in 2006?
Give a very brief answer. 3.48e+06. What is the difference between the Aid flow (current US$) of High income: OECD in 2005 and the Aid flow (current US$) of Chile in 2007?
Provide a succinct answer. 3.70e+05. What is the difference between the Aid flow (current US$) in High income: OECD in 2005 and the Aid flow (current US$) in Timor-Leste in 2007?
Keep it short and to the point. 5.90e+05. What is the difference between the Aid flow (current US$) of High income: OECD in 2005 and the Aid flow (current US$) of Turks and Caicos Islands in 2007?
Ensure brevity in your answer.  1.67e+06. What is the difference between the Aid flow (current US$) of Chile in 2005 and the Aid flow (current US$) of Timor-Leste in 2007?
Provide a succinct answer. 5.90e+05. What is the difference between the Aid flow (current US$) of Chile in 2005 and the Aid flow (current US$) of Turks and Caicos Islands in 2007?
Ensure brevity in your answer.  1.67e+06. What is the difference between the Aid flow (current US$) in Timor-Leste in 2005 and the Aid flow (current US$) in Turks and Caicos Islands in 2007?
Give a very brief answer. 1.33e+06. What is the difference between the Aid flow (current US$) in High income: OECD in 2006 and the Aid flow (current US$) in Chile in 2007?
Offer a very short reply. -9.20e+05. What is the difference between the Aid flow (current US$) in High income: OECD in 2006 and the Aid flow (current US$) in Timor-Leste in 2007?
Give a very brief answer. -7.00e+05. What is the difference between the Aid flow (current US$) in High income: OECD in 2006 and the Aid flow (current US$) in Turks and Caicos Islands in 2007?
Ensure brevity in your answer.  3.80e+05. What is the difference between the Aid flow (current US$) in Chile in 2006 and the Aid flow (current US$) in Timor-Leste in 2007?
Offer a terse response. -7.00e+05. What is the difference between the Aid flow (current US$) of Chile in 2006 and the Aid flow (current US$) of Turks and Caicos Islands in 2007?
Make the answer very short. 3.80e+05. What is the difference between the Aid flow (current US$) of Timor-Leste in 2006 and the Aid flow (current US$) of Turks and Caicos Islands in 2007?
Your response must be concise. -3.50e+05. What is the average Aid flow (current US$) in High income: OECD per year?
Your answer should be compact. 5.62e+07. What is the average Aid flow (current US$) of Chile per year?
Offer a terse response. 2.40e+06. What is the average Aid flow (current US$) of Timor-Leste per year?
Provide a succinct answer. 2.84e+06. In the year 2000, what is the difference between the Aid flow (current US$) of High income: OECD and Aid flow (current US$) of Chile?
Your response must be concise. 1.24e+08. In the year 2000, what is the difference between the Aid flow (current US$) in High income: OECD and Aid flow (current US$) in Timor-Leste?
Give a very brief answer. 1.25e+08. In the year 2000, what is the difference between the Aid flow (current US$) in High income: OECD and Aid flow (current US$) in Turks and Caicos Islands?
Your answer should be very brief. 1.25e+08. In the year 2000, what is the difference between the Aid flow (current US$) of Chile and Aid flow (current US$) of Turks and Caicos Islands?
Provide a succinct answer. 7.70e+05. In the year 2000, what is the difference between the Aid flow (current US$) in Timor-Leste and Aid flow (current US$) in Turks and Caicos Islands?
Your response must be concise. 4.90e+05. In the year 2001, what is the difference between the Aid flow (current US$) in High income: OECD and Aid flow (current US$) in Chile?
Offer a terse response. 1.15e+08. In the year 2001, what is the difference between the Aid flow (current US$) in High income: OECD and Aid flow (current US$) in Timor-Leste?
Make the answer very short. 1.13e+08. In the year 2001, what is the difference between the Aid flow (current US$) of High income: OECD and Aid flow (current US$) of Turks and Caicos Islands?
Give a very brief answer. 1.16e+08. In the year 2001, what is the difference between the Aid flow (current US$) of Chile and Aid flow (current US$) of Timor-Leste?
Give a very brief answer. -2.13e+06. In the year 2001, what is the difference between the Aid flow (current US$) of Timor-Leste and Aid flow (current US$) of Turks and Caicos Islands?
Offer a terse response. 2.60e+06. In the year 2002, what is the difference between the Aid flow (current US$) of High income: OECD and Aid flow (current US$) of Chile?
Provide a short and direct response. 7.21e+07. In the year 2002, what is the difference between the Aid flow (current US$) of High income: OECD and Aid flow (current US$) of Timor-Leste?
Your response must be concise. 7.06e+07. In the year 2002, what is the difference between the Aid flow (current US$) of High income: OECD and Aid flow (current US$) of Turks and Caicos Islands?
Provide a succinct answer. 7.36e+07. In the year 2002, what is the difference between the Aid flow (current US$) of Chile and Aid flow (current US$) of Timor-Leste?
Provide a succinct answer. -1.46e+06. In the year 2002, what is the difference between the Aid flow (current US$) of Chile and Aid flow (current US$) of Turks and Caicos Islands?
Offer a very short reply. 1.48e+06. In the year 2002, what is the difference between the Aid flow (current US$) of Timor-Leste and Aid flow (current US$) of Turks and Caicos Islands?
Offer a very short reply. 2.94e+06. In the year 2003, what is the difference between the Aid flow (current US$) in High income: OECD and Aid flow (current US$) in Chile?
Provide a succinct answer. 6.37e+07. In the year 2003, what is the difference between the Aid flow (current US$) in High income: OECD and Aid flow (current US$) in Timor-Leste?
Your response must be concise. 6.15e+07. In the year 2003, what is the difference between the Aid flow (current US$) of High income: OECD and Aid flow (current US$) of Turks and Caicos Islands?
Keep it short and to the point. 6.64e+07. In the year 2003, what is the difference between the Aid flow (current US$) in Chile and Aid flow (current US$) in Timor-Leste?
Ensure brevity in your answer.  -2.20e+06. In the year 2003, what is the difference between the Aid flow (current US$) in Chile and Aid flow (current US$) in Turks and Caicos Islands?
Make the answer very short. 2.71e+06. In the year 2003, what is the difference between the Aid flow (current US$) in Timor-Leste and Aid flow (current US$) in Turks and Caicos Islands?
Offer a very short reply. 4.91e+06. In the year 2004, what is the difference between the Aid flow (current US$) of High income: OECD and Aid flow (current US$) of Chile?
Provide a succinct answer. 5.50e+07. In the year 2004, what is the difference between the Aid flow (current US$) of High income: OECD and Aid flow (current US$) of Timor-Leste?
Your response must be concise. 5.58e+07. In the year 2004, what is the difference between the Aid flow (current US$) in High income: OECD and Aid flow (current US$) in Turks and Caicos Islands?
Your answer should be very brief. 5.84e+07. In the year 2004, what is the difference between the Aid flow (current US$) of Chile and Aid flow (current US$) of Timor-Leste?
Provide a succinct answer. 7.50e+05. In the year 2004, what is the difference between the Aid flow (current US$) of Chile and Aid flow (current US$) of Turks and Caicos Islands?
Your answer should be very brief. 3.41e+06. In the year 2004, what is the difference between the Aid flow (current US$) of Timor-Leste and Aid flow (current US$) of Turks and Caicos Islands?
Your answer should be compact. 2.66e+06. In the year 2005, what is the difference between the Aid flow (current US$) in High income: OECD and Aid flow (current US$) in Timor-Leste?
Your answer should be very brief. 3.40e+05. In the year 2005, what is the difference between the Aid flow (current US$) of High income: OECD and Aid flow (current US$) of Turks and Caicos Islands?
Provide a succinct answer. 2.63e+06. In the year 2005, what is the difference between the Aid flow (current US$) of Chile and Aid flow (current US$) of Turks and Caicos Islands?
Give a very brief answer. 2.63e+06. In the year 2005, what is the difference between the Aid flow (current US$) in Timor-Leste and Aid flow (current US$) in Turks and Caicos Islands?
Provide a short and direct response. 2.29e+06. In the year 2006, what is the difference between the Aid flow (current US$) in High income: OECD and Aid flow (current US$) in Chile?
Your response must be concise. 0. In the year 2006, what is the difference between the Aid flow (current US$) in High income: OECD and Aid flow (current US$) in Timor-Leste?
Your response must be concise. 7.30e+05. In the year 2006, what is the difference between the Aid flow (current US$) in High income: OECD and Aid flow (current US$) in Turks and Caicos Islands?
Offer a very short reply. 2.53e+06. In the year 2006, what is the difference between the Aid flow (current US$) of Chile and Aid flow (current US$) of Timor-Leste?
Provide a succinct answer. 7.30e+05. In the year 2006, what is the difference between the Aid flow (current US$) in Chile and Aid flow (current US$) in Turks and Caicos Islands?
Make the answer very short. 2.53e+06. In the year 2006, what is the difference between the Aid flow (current US$) in Timor-Leste and Aid flow (current US$) in Turks and Caicos Islands?
Offer a terse response. 1.80e+06. In the year 2007, what is the difference between the Aid flow (current US$) of High income: OECD and Aid flow (current US$) of Chile?
Give a very brief answer. 0. In the year 2007, what is the difference between the Aid flow (current US$) of High income: OECD and Aid flow (current US$) of Turks and Caicos Islands?
Keep it short and to the point. 1.30e+06. In the year 2007, what is the difference between the Aid flow (current US$) in Chile and Aid flow (current US$) in Turks and Caicos Islands?
Offer a very short reply. 1.30e+06. In the year 2007, what is the difference between the Aid flow (current US$) in Timor-Leste and Aid flow (current US$) in Turks and Caicos Islands?
Give a very brief answer. 1.08e+06. What is the ratio of the Aid flow (current US$) of High income: OECD in 2000 to that in 2001?
Your answer should be compact. 1.08. What is the ratio of the Aid flow (current US$) of Chile in 2000 to that in 2001?
Offer a terse response. 1.23. What is the ratio of the Aid flow (current US$) of Timor-Leste in 2000 to that in 2001?
Offer a terse response. 0.19. What is the ratio of the Aid flow (current US$) in High income: OECD in 2000 to that in 2002?
Your answer should be very brief. 1.7. What is the ratio of the Aid flow (current US$) of Chile in 2000 to that in 2002?
Provide a succinct answer. 0.49. What is the ratio of the Aid flow (current US$) of Timor-Leste in 2000 to that in 2002?
Offer a terse response. 0.17. What is the ratio of the Aid flow (current US$) of Turks and Caicos Islands in 2000 to that in 2002?
Provide a succinct answer. 0.2. What is the ratio of the Aid flow (current US$) in High income: OECD in 2000 to that in 2003?
Offer a very short reply. 1.88. What is the ratio of the Aid flow (current US$) in Chile in 2000 to that in 2003?
Make the answer very short. 0.29. What is the ratio of the Aid flow (current US$) in Timor-Leste in 2000 to that in 2003?
Give a very brief answer. 0.1. What is the ratio of the Aid flow (current US$) of Turks and Caicos Islands in 2000 to that in 2003?
Your response must be concise. 0.38. What is the ratio of the Aid flow (current US$) of High income: OECD in 2000 to that in 2004?
Your response must be concise. 2.14. What is the ratio of the Aid flow (current US$) of Chile in 2000 to that in 2004?
Offer a very short reply. 0.23. What is the ratio of the Aid flow (current US$) of Timor-Leste in 2000 to that in 2004?
Make the answer very short. 0.19. What is the ratio of the Aid flow (current US$) of Turks and Caicos Islands in 2000 to that in 2004?
Provide a short and direct response. 0.27. What is the ratio of the Aid flow (current US$) in High income: OECD in 2000 to that in 2005?
Provide a short and direct response. 32.69. What is the ratio of the Aid flow (current US$) of Chile in 2000 to that in 2005?
Your response must be concise. 0.21. What is the ratio of the Aid flow (current US$) in Timor-Leste in 2000 to that in 2005?
Your answer should be very brief. 0.15. What is the ratio of the Aid flow (current US$) in Turks and Caicos Islands in 2000 to that in 2005?
Keep it short and to the point. 0.03. What is the ratio of the Aid flow (current US$) in High income: OECD in 2000 to that in 2006?
Provide a succinct answer. 49.3. What is the ratio of the Aid flow (current US$) of Chile in 2000 to that in 2006?
Offer a very short reply. 0.32. What is the ratio of the Aid flow (current US$) in Timor-Leste in 2000 to that in 2006?
Your answer should be very brief. 0.29. What is the ratio of the Aid flow (current US$) in High income: OECD in 2000 to that in 2007?
Keep it short and to the point. 36.19. What is the ratio of the Aid flow (current US$) in Chile in 2000 to that in 2007?
Your response must be concise. 0.23. What is the ratio of the Aid flow (current US$) of Timor-Leste in 2000 to that in 2007?
Ensure brevity in your answer.  0.16. What is the ratio of the Aid flow (current US$) of Turks and Caicos Islands in 2000 to that in 2007?
Give a very brief answer. 0.01. What is the ratio of the Aid flow (current US$) in High income: OECD in 2001 to that in 2002?
Ensure brevity in your answer.  1.57. What is the ratio of the Aid flow (current US$) in Chile in 2001 to that in 2002?
Your answer should be very brief. 0.4. What is the ratio of the Aid flow (current US$) in Timor-Leste in 2001 to that in 2002?
Provide a short and direct response. 0.9. What is the ratio of the Aid flow (current US$) in High income: OECD in 2001 to that in 2003?
Provide a short and direct response. 1.74. What is the ratio of the Aid flow (current US$) of Chile in 2001 to that in 2003?
Keep it short and to the point. 0.23. What is the ratio of the Aid flow (current US$) of Timor-Leste in 2001 to that in 2003?
Make the answer very short. 0.56. What is the ratio of the Aid flow (current US$) of Turks and Caicos Islands in 2001 to that in 2003?
Offer a very short reply. 2.25. What is the ratio of the Aid flow (current US$) in High income: OECD in 2001 to that in 2004?
Offer a very short reply. 1.98. What is the ratio of the Aid flow (current US$) of Chile in 2001 to that in 2004?
Give a very brief answer. 0.18. What is the ratio of the Aid flow (current US$) of Timor-Leste in 2001 to that in 2004?
Provide a short and direct response. 1. What is the ratio of the Aid flow (current US$) of Turks and Caicos Islands in 2001 to that in 2004?
Give a very brief answer. 1.64. What is the ratio of the Aid flow (current US$) of High income: OECD in 2001 to that in 2005?
Your answer should be compact. 30.26. What is the ratio of the Aid flow (current US$) in Chile in 2001 to that in 2005?
Give a very brief answer. 0.17. What is the ratio of the Aid flow (current US$) in Timor-Leste in 2001 to that in 2005?
Offer a very short reply. 0.8. What is the ratio of the Aid flow (current US$) in High income: OECD in 2001 to that in 2006?
Make the answer very short. 45.62. What is the ratio of the Aid flow (current US$) of Chile in 2001 to that in 2006?
Provide a succinct answer. 0.26. What is the ratio of the Aid flow (current US$) in Timor-Leste in 2001 to that in 2006?
Provide a short and direct response. 1.54. What is the ratio of the Aid flow (current US$) of High income: OECD in 2001 to that in 2007?
Your answer should be compact. 33.49. What is the ratio of the Aid flow (current US$) in Chile in 2001 to that in 2007?
Provide a succinct answer. 0.19. What is the ratio of the Aid flow (current US$) of Timor-Leste in 2001 to that in 2007?
Make the answer very short. 0.86. What is the ratio of the Aid flow (current US$) of Turks and Caicos Islands in 2001 to that in 2007?
Offer a terse response. 0.08. What is the ratio of the Aid flow (current US$) of High income: OECD in 2002 to that in 2003?
Offer a terse response. 1.11. What is the ratio of the Aid flow (current US$) in Chile in 2002 to that in 2003?
Offer a terse response. 0.58. What is the ratio of the Aid flow (current US$) in Timor-Leste in 2002 to that in 2003?
Ensure brevity in your answer.  0.62. What is the ratio of the Aid flow (current US$) in Turks and Caicos Islands in 2002 to that in 2003?
Give a very brief answer. 1.88. What is the ratio of the Aid flow (current US$) of High income: OECD in 2002 to that in 2004?
Make the answer very short. 1.26. What is the ratio of the Aid flow (current US$) of Chile in 2002 to that in 2004?
Your response must be concise. 0.46. What is the ratio of the Aid flow (current US$) in Timor-Leste in 2002 to that in 2004?
Keep it short and to the point. 1.12. What is the ratio of the Aid flow (current US$) in Turks and Caicos Islands in 2002 to that in 2004?
Make the answer very short. 1.36. What is the ratio of the Aid flow (current US$) of High income: OECD in 2002 to that in 2005?
Your response must be concise. 19.25. What is the ratio of the Aid flow (current US$) of Chile in 2002 to that in 2005?
Offer a terse response. 0.43. What is the ratio of the Aid flow (current US$) of Timor-Leste in 2002 to that in 2005?
Make the answer very short. 0.89. What is the ratio of the Aid flow (current US$) of High income: OECD in 2002 to that in 2006?
Offer a very short reply. 29.03. What is the ratio of the Aid flow (current US$) of Chile in 2002 to that in 2006?
Your answer should be compact. 0.64. What is the ratio of the Aid flow (current US$) in Timor-Leste in 2002 to that in 2006?
Provide a short and direct response. 1.71. What is the ratio of the Aid flow (current US$) of High income: OECD in 2002 to that in 2007?
Offer a very short reply. 21.31. What is the ratio of the Aid flow (current US$) of Chile in 2002 to that in 2007?
Provide a succinct answer. 0.47. What is the ratio of the Aid flow (current US$) in Timor-Leste in 2002 to that in 2007?
Offer a very short reply. 0.95. What is the ratio of the Aid flow (current US$) in Turks and Caicos Islands in 2002 to that in 2007?
Your response must be concise. 0.07. What is the ratio of the Aid flow (current US$) of High income: OECD in 2003 to that in 2004?
Give a very brief answer. 1.14. What is the ratio of the Aid flow (current US$) of Chile in 2003 to that in 2004?
Your answer should be very brief. 0.79. What is the ratio of the Aid flow (current US$) of Timor-Leste in 2003 to that in 2004?
Keep it short and to the point. 1.8. What is the ratio of the Aid flow (current US$) of Turks and Caicos Islands in 2003 to that in 2004?
Make the answer very short. 0.73. What is the ratio of the Aid flow (current US$) of High income: OECD in 2003 to that in 2005?
Keep it short and to the point. 17.36. What is the ratio of the Aid flow (current US$) of Chile in 2003 to that in 2005?
Keep it short and to the point. 0.73. What is the ratio of the Aid flow (current US$) in Timor-Leste in 2003 to that in 2005?
Make the answer very short. 1.43. What is the ratio of the Aid flow (current US$) of Turks and Caicos Islands in 2003 to that in 2005?
Your answer should be very brief. 0.07. What is the ratio of the Aid flow (current US$) of High income: OECD in 2003 to that in 2006?
Ensure brevity in your answer.  26.18. What is the ratio of the Aid flow (current US$) of Chile in 2003 to that in 2006?
Give a very brief answer. 1.1. What is the ratio of the Aid flow (current US$) in Timor-Leste in 2003 to that in 2006?
Give a very brief answer. 2.76. What is the ratio of the Aid flow (current US$) in High income: OECD in 2003 to that in 2007?
Your answer should be compact. 19.22. What is the ratio of the Aid flow (current US$) in Chile in 2003 to that in 2007?
Your response must be concise. 0.81. What is the ratio of the Aid flow (current US$) in Timor-Leste in 2003 to that in 2007?
Your answer should be very brief. 1.54. What is the ratio of the Aid flow (current US$) of Turks and Caicos Islands in 2003 to that in 2007?
Your answer should be compact. 0.04. What is the ratio of the Aid flow (current US$) of High income: OECD in 2004 to that in 2005?
Provide a short and direct response. 15.28. What is the ratio of the Aid flow (current US$) of Chile in 2004 to that in 2005?
Give a very brief answer. 0.92. What is the ratio of the Aid flow (current US$) in Timor-Leste in 2004 to that in 2005?
Provide a succinct answer. 0.79. What is the ratio of the Aid flow (current US$) in Turks and Caicos Islands in 2004 to that in 2005?
Make the answer very short. 0.09. What is the ratio of the Aid flow (current US$) in High income: OECD in 2004 to that in 2006?
Offer a terse response. 23.05. What is the ratio of the Aid flow (current US$) in Chile in 2004 to that in 2006?
Keep it short and to the point. 1.39. What is the ratio of the Aid flow (current US$) of Timor-Leste in 2004 to that in 2006?
Offer a terse response. 1.53. What is the ratio of the Aid flow (current US$) in High income: OECD in 2004 to that in 2007?
Give a very brief answer. 16.92. What is the ratio of the Aid flow (current US$) in Chile in 2004 to that in 2007?
Provide a succinct answer. 1.02. What is the ratio of the Aid flow (current US$) in Timor-Leste in 2004 to that in 2007?
Your response must be concise. 0.85. What is the ratio of the Aid flow (current US$) in Turks and Caicos Islands in 2004 to that in 2007?
Keep it short and to the point. 0.05. What is the ratio of the Aid flow (current US$) in High income: OECD in 2005 to that in 2006?
Your response must be concise. 1.51. What is the ratio of the Aid flow (current US$) of Chile in 2005 to that in 2006?
Offer a very short reply. 1.51. What is the ratio of the Aid flow (current US$) of Timor-Leste in 2005 to that in 2006?
Your response must be concise. 1.93. What is the ratio of the Aid flow (current US$) of Turks and Caicos Islands in 2005 to that in 2006?
Your response must be concise. 120. What is the ratio of the Aid flow (current US$) of High income: OECD in 2005 to that in 2007?
Your response must be concise. 1.11. What is the ratio of the Aid flow (current US$) of Chile in 2005 to that in 2007?
Offer a very short reply. 1.11. What is the ratio of the Aid flow (current US$) of Timor-Leste in 2005 to that in 2007?
Keep it short and to the point. 1.08. What is the ratio of the Aid flow (current US$) of Turks and Caicos Islands in 2005 to that in 2007?
Offer a terse response. 0.56. What is the ratio of the Aid flow (current US$) of High income: OECD in 2006 to that in 2007?
Keep it short and to the point. 0.73. What is the ratio of the Aid flow (current US$) of Chile in 2006 to that in 2007?
Your answer should be very brief. 0.73. What is the ratio of the Aid flow (current US$) in Timor-Leste in 2006 to that in 2007?
Provide a short and direct response. 0.56. What is the ratio of the Aid flow (current US$) of Turks and Caicos Islands in 2006 to that in 2007?
Give a very brief answer. 0. What is the difference between the highest and the second highest Aid flow (current US$) of High income: OECD?
Provide a short and direct response. 9.33e+06. What is the difference between the highest and the second highest Aid flow (current US$) of Chile?
Provide a short and direct response. 3.10e+05. What is the difference between the highest and the second highest Aid flow (current US$) in Timor-Leste?
Give a very brief answer. 1.50e+06. What is the difference between the highest and the second highest Aid flow (current US$) of Turks and Caicos Islands?
Your answer should be compact. 9.60e+05. What is the difference between the highest and the lowest Aid flow (current US$) in High income: OECD?
Your answer should be compact. 1.23e+08. What is the difference between the highest and the lowest Aid flow (current US$) of Chile?
Offer a terse response. 3.18e+06. What is the difference between the highest and the lowest Aid flow (current US$) in Timor-Leste?
Offer a terse response. 4.47e+06. What is the difference between the highest and the lowest Aid flow (current US$) of Turks and Caicos Islands?
Offer a very short reply. 2.15e+06. 